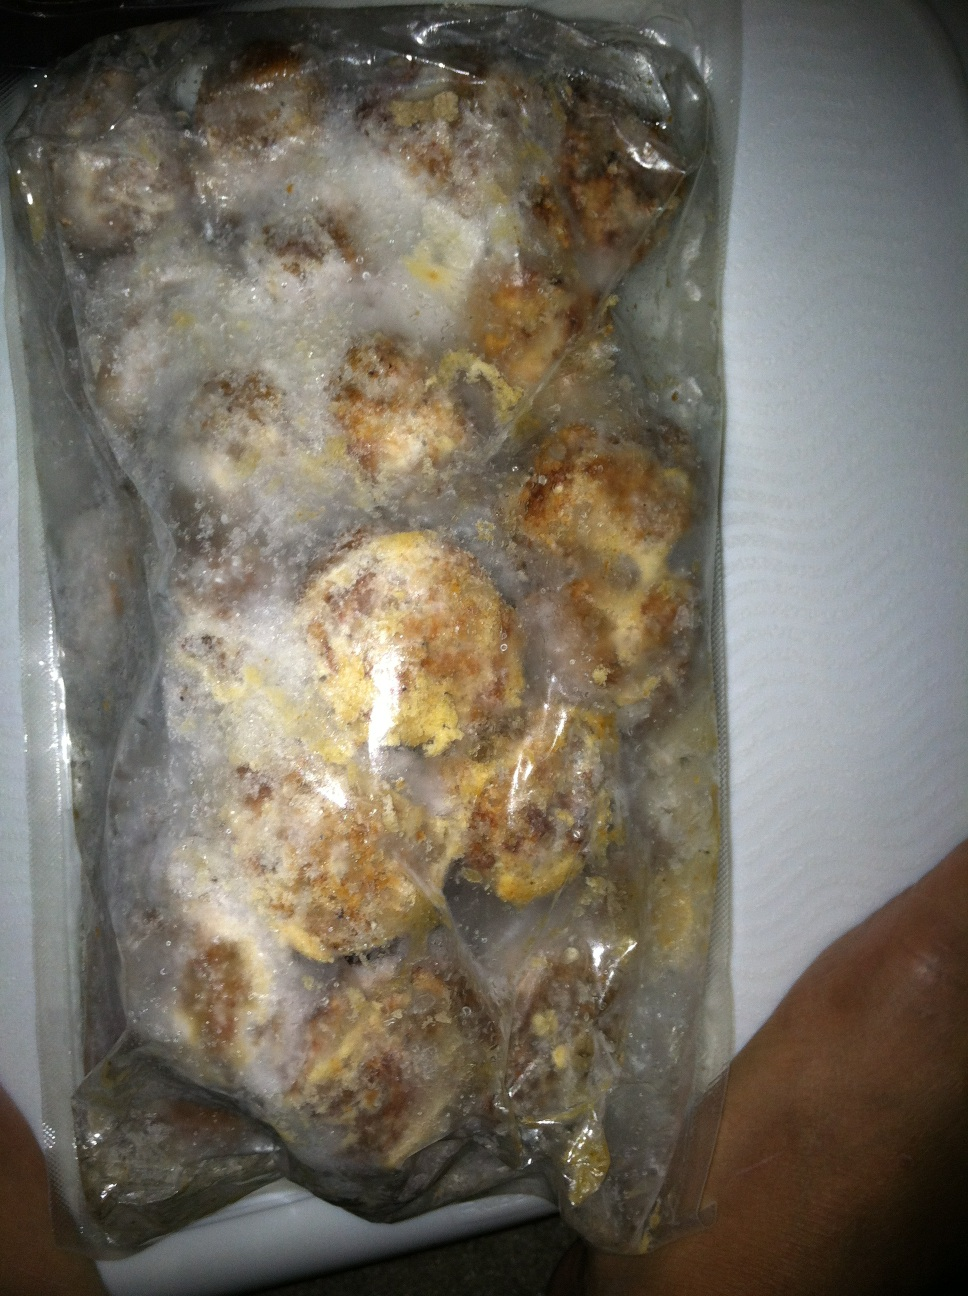Could this package be part of an emergency food supply? Yes, this package of frozen meatballs could indeed be part of an emergency food supply. Having pre-prepared meals in the freezer can be very handy in times when fresh ingredients are not available. These meatballs could provide a substantial and comforting meal during emergencies. 